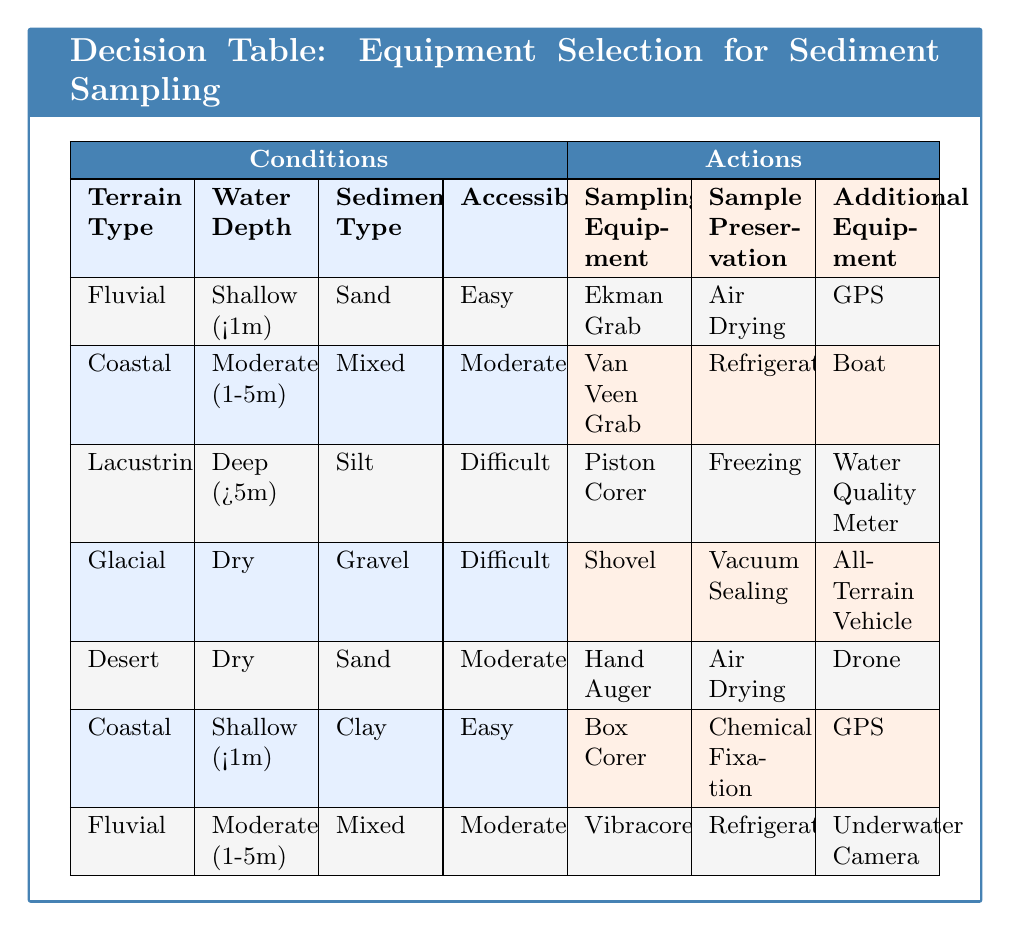What sampling equipment is recommended for Coastal terrain with Moderate water depth and Mixed sediment type? In the table, under the conditions for Coastal terrain with Moderate water depth and Mixed sediment type, the recommended sampling equipment is listed as Van Veen Grab.
Answer: Van Veen Grab What type of preservation is suggested for sampling in Lacustrine environments with Deep water and Silt sediment? Referring to the table for Lacustrine environments with Deep water and Silt sediment, the suggested sample preservation method is Freezing.
Answer: Freezing Is Air Drying used as a preservation method for any sampling equipment in Fluvial terrains? By examining the table, Air Drying is used for sampling equipment under Fluvial terrain with Shallow water and Sand sediment. Therefore, the answer is yes.
Answer: Yes Which additional equipment is associated with sampling in Glacial terrain? The table states that the additional equipment required for sampling in Glacial terrain is an All-Terrain Vehicle.
Answer: All-Terrain Vehicle How many sampling equipment options are available when the sediment type is Clay in Coastal terrain with Shallow water? Looking through the table, for Coastal terrain with Shallow water and Clay sediment, the sampling equipment options are Box Corer. Therefore, there is 1 option available for this condition.
Answer: 1 What is the recommended sampling equipment for Desert terrain with Dry conditions? In the table, for Desert terrain with Dry conditions and Sand sediment, the recommended sampling equipment is Hand Auger.
Answer: Hand Auger Does the table suggest using a GPS device in any of the sampling scenarios? Checking the table reveals that GPS is suggested for sampling in both Fluvial terrain with Shallow water and Sand sediment, and Coastal terrain with Shallow water and Clay sediment, confirming that GPS is indeed used.
Answer: Yes What can you conclude about the preservation methods for sampling equipment in Dry sediment conditions? Analyzing the table shows that for both Glacial terrain and Desert terrain with Dry conditions, the preservation methods are Vacuum Sealing and Air Drying, respectively. Thus, two different methods are used for Dry sediment conditions.
Answer: Two methods For Coastal terrains with Moderate water depth and accessibility marked as Moderate, which equipment is preferred? The table specifies that for Coastal terrains with Moderate water depth and a Moderate level of accessibility, the preferred equipment is the Van Veen Grab.
Answer: Van Veen Grab 